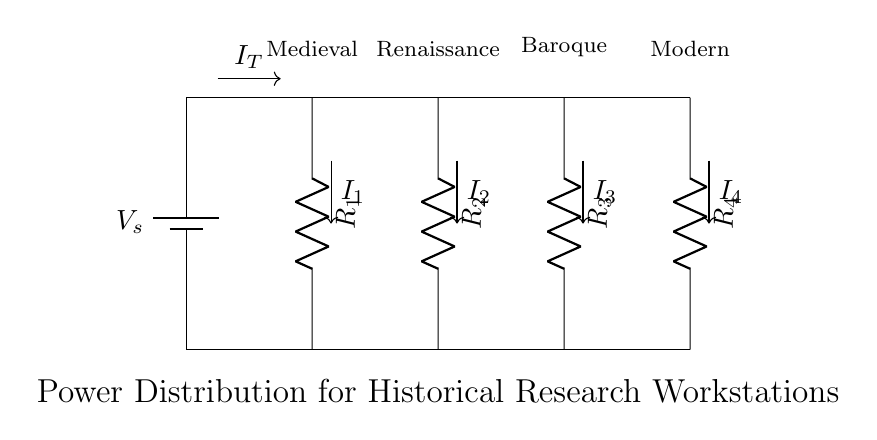What is the total current entering the circuit? The total current entering the circuit is represented as I_T, which is the current before it splits into the branches.
Answer: I_T How many resistors are in the circuit? By examining the diagram, there are four resistors labeled R_1, R_2, R_3, and R_4.
Answer: Four Which branch has the highest current? The current in each branch is inversely proportional to the resistance. Without specified values, we cannot definitively determine which branch has the highest current, but if the resistors have equal resistance, all branches would have equal currents.
Answer: Cannot determine What voltage is supplied by the power source? There is no explicit voltage value provided in the circuit diagram. It is referred to as V_s.
Answer: V_s How does the circuit distribute power among the workstations? The circuit is a parallel design, meaning each workstation receives the same voltage (V_s), while the current varies between branches based on the resistances of R_1, R_2, R_3, and R_4.
Answer: Parallel configuration What happens to the branch currents if R_1 is decreased? If R_1 is decreased, the current I_1 will increase according to Ohm's Law, resulting in a greater share of the total current. This will affect the branch currents due to the overall change in resistance in the circuit.
Answer: I_1 increases 